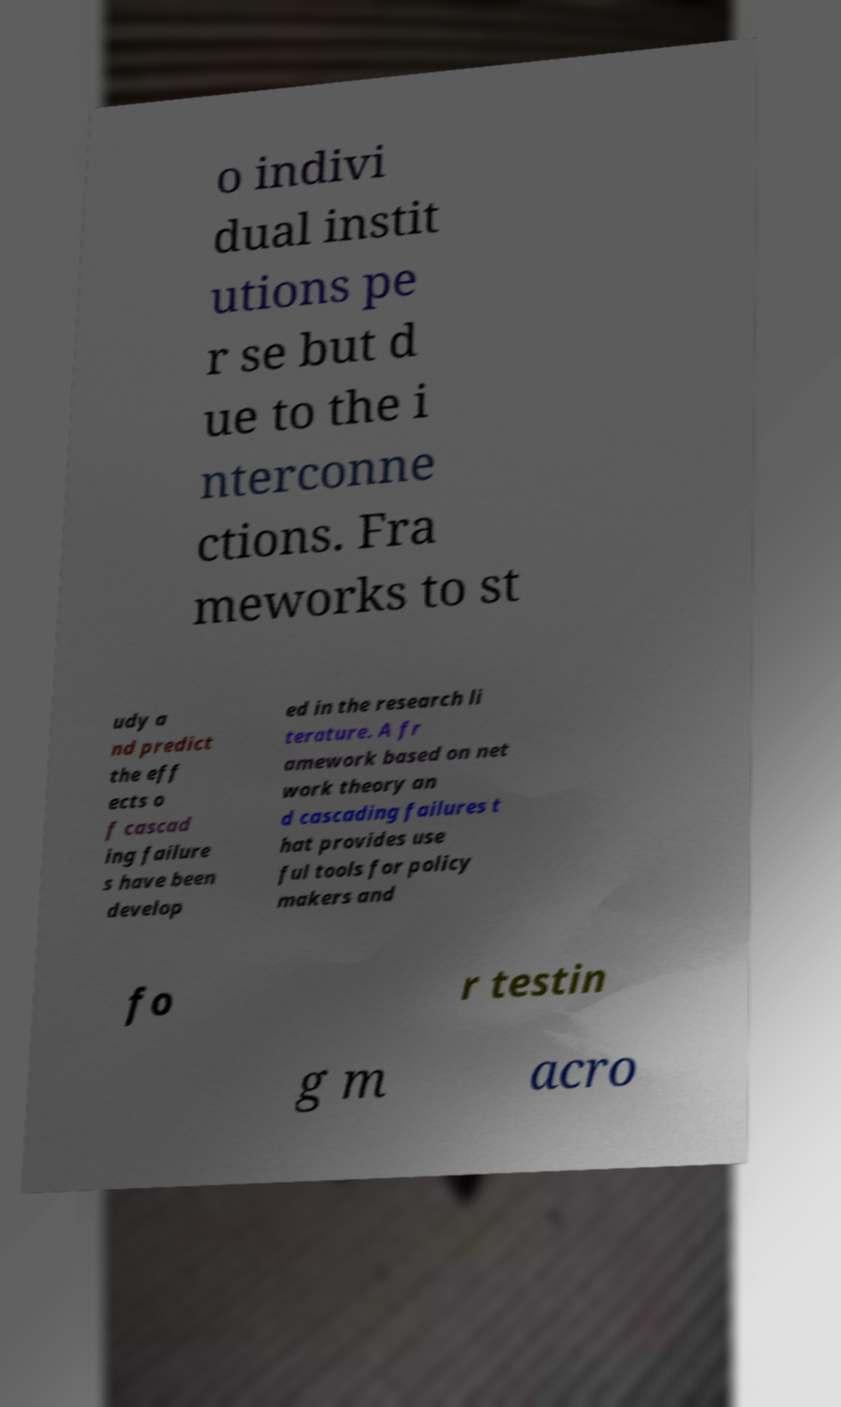For documentation purposes, I need the text within this image transcribed. Could you provide that? o indivi dual instit utions pe r se but d ue to the i nterconne ctions. Fra meworks to st udy a nd predict the eff ects o f cascad ing failure s have been develop ed in the research li terature. A fr amework based on net work theory an d cascading failures t hat provides use ful tools for policy makers and fo r testin g m acro 